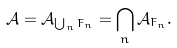Convert formula to latex. <formula><loc_0><loc_0><loc_500><loc_500>\mathcal { A } = \mathcal { A } _ { \bigcup _ { n } F _ { n } } = \bigcap _ { n } \mathcal { A } _ { F _ { n } } .</formula> 